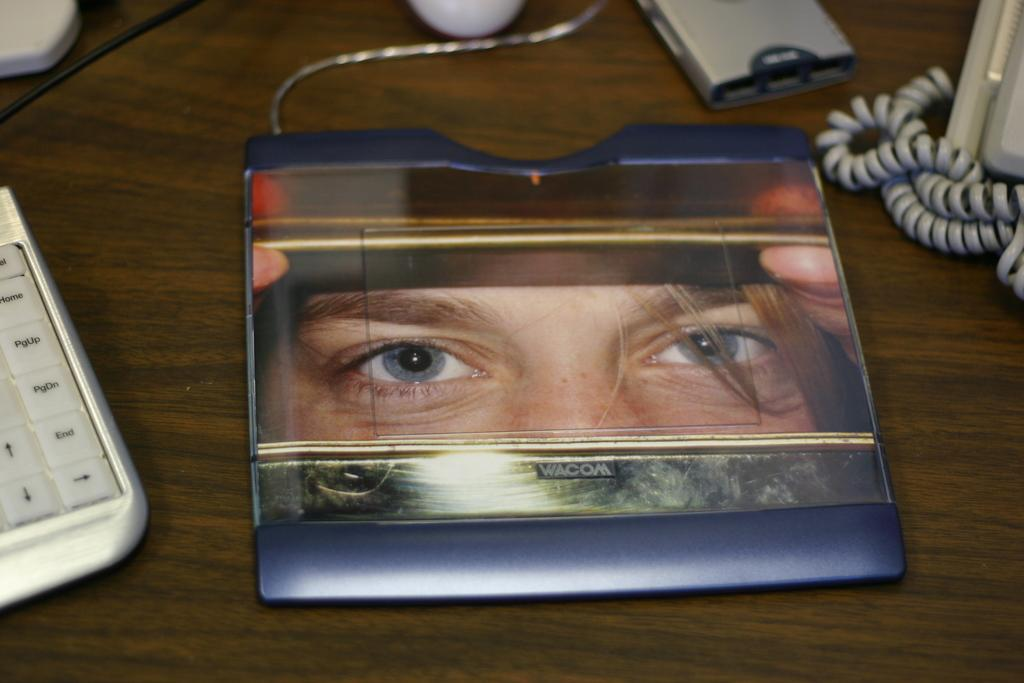What type of table is in the image? There is a wooden table in the image. What is on the table? There is an electronic device on the table. What can be seen on the electronic device? The electronic device has an image of a person. What is located on the left side of the table? There is a keyboard on the left side of the table. What is on the right side of the table? There is a wire on the right side of the table. What is the name of the daughter of the person in the image on the electronic device? There is no daughter mentioned in the image, as it only shows an electronic device with an image of a person. 